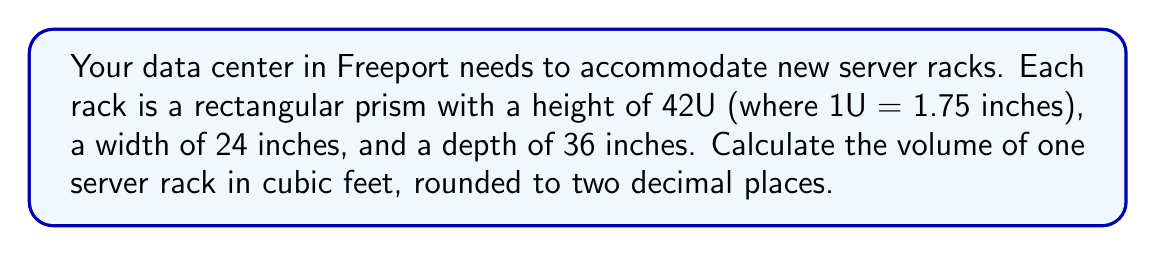Teach me how to tackle this problem. To calculate the volume of the server rack, we need to:

1. Convert all dimensions to feet:
   Height: $42 \times 1.75 \text{ inches} = 73.5 \text{ inches} = \frac{73.5}{12} = 6.125 \text{ feet}$
   Width: $24 \text{ inches} = \frac{24}{12} = 2 \text{ feet}$
   Depth: $36 \text{ inches} = \frac{36}{12} = 3 \text{ feet}$

2. Apply the volume formula for a rectangular prism:
   $$V = l \times w \times h$$
   Where $V$ is volume, $l$ is length (depth in this case), $w$ is width, and $h$ is height.

3. Substitute the values:
   $$V = 3 \times 2 \times 6.125$$

4. Calculate:
   $$V = 36.75 \text{ cubic feet}$$

5. Round to two decimal places:
   $$V \approx 36.75 \text{ cubic feet}$$
Answer: 36.75 cubic feet 